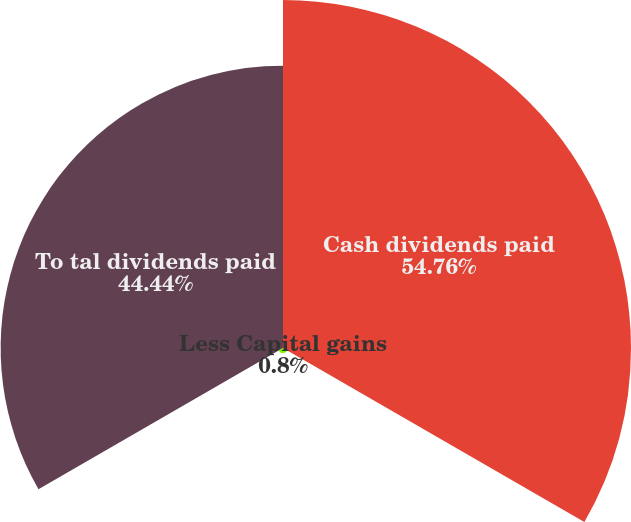Convert chart. <chart><loc_0><loc_0><loc_500><loc_500><pie_chart><fcel>Cash dividends paid<fcel>Less Capital gains<fcel>To tal dividends paid<nl><fcel>54.77%<fcel>0.8%<fcel>44.44%<nl></chart> 